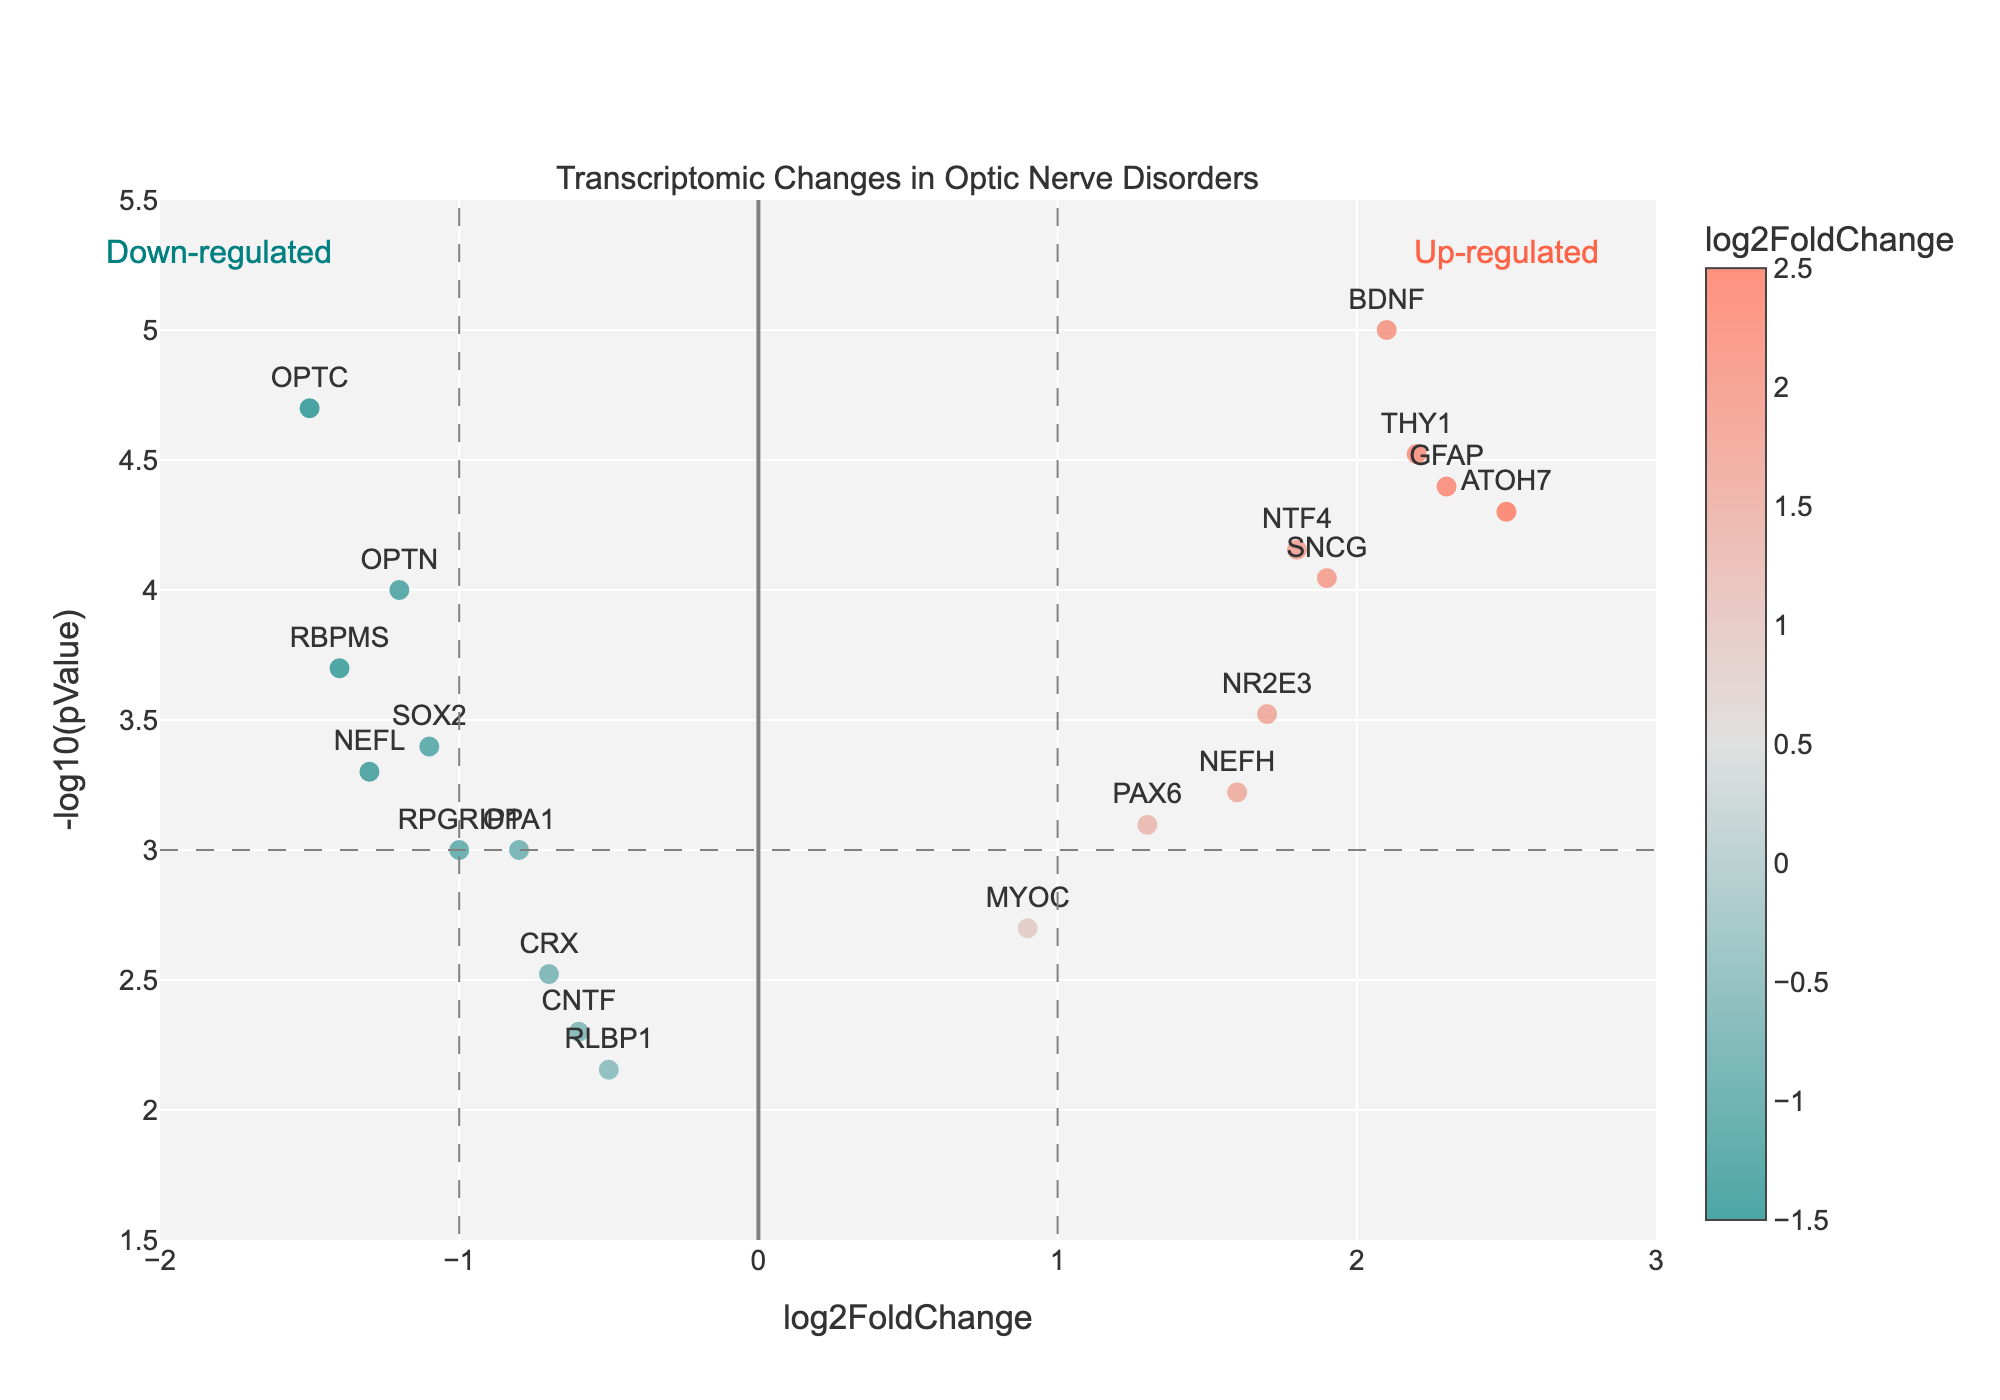What's the title of the plot? The title is usually displayed at the top of the plot, providing an overview of what the plot is about. Here, it is "Transcriptomic Changes in Optic Nerve Disorders."
Answer: Transcriptomic Changes in Optic Nerve Disorders What is represented on the x-axis? The x-axis in a volcano plot typically shows the log2FoldChange, which measures the change in expression levels of genes. It helps in identifying which genes are up-regulated or down-regulated.
Answer: log2FoldChange What is plotted on the y-axis? The y-axis in a volcano plot represents the negative log10 of the p-values (-log10(pValue)). This helps to identify the significance of the changes in gene expression, with higher values indicating more significant changes.
Answer: -log10(pValue) How many genes are up-regulated with a significant p-value (less than 0.001)? To find the number of up-regulated genes with significant p-values, we can visually inspect the right side of the volcano plot (log2FoldChange > 1) and check if their y-values are high (above the threshold line representing p-value < 0.001). Genes like ATOH7, BDNF, GFAP, NTF4, SNCG, and THY1 meet these criteria.
Answer: 6 Which gene shows the highest negative log2FoldChange and how significant is its change? The gene with the most negative log2FoldChange is identified by locating the point farthest to the left on the x-axis. OPTC shows the highest negative log2FoldChange (-1.5). We can also check its significance by its y-value (high on the y-axis), indicating a very significant change.
Answer: OPTC, highly significant (p-value < 0.001) Which gene has the highest expression change post-treatment? The highest expression change (log2FoldChange) can be found by identifying the point farthest to the right on the x-axis. ATOH7 has the highest positive log2FoldChange of 2.5.
Answer: ATOH7 What can you infer about the gene with the lowest significance? The gene with the lowest significance will have the smallest -log10(pValue), which corresponds to the lowest point on the y-axis. RLBP1 has a -log10(pValue) of about 2, indicating it is the least significant among the plotted genes.
Answer: RLBP1 is the least significant Are there more up-regulated or down-regulated genes with p-values < 0.01? To compare, we can count the number of genes with log2FoldChange > 0 (up-regulated) and p-value < 0.01, and those with log2FoldChange < 0 (down-regulated) and p-value < 0.01. There are more up-regulated genes (ATOH7, BDNF, NTF4, GFAP, SNCG, THY1) than down-regulated ones (OPTN, OPTC, RBPMS, NEFL).
Answer: More up-regulated genes (6 vs 4) Which genes are considered highly significant (p-value < 0.0001) and how are they regulated? Highly significant genes are identified by their high -log10(pValue) values. Genes with p-values < 0.0001 (log10(pValue) > 4) are OPTN, ATOH7, OPTC, BDNF, NTF4, GFAP, THY1. According to their log2FoldChange, ATOH7, BDNF, NTF4, GFAP, THY1 are up-regulated, while OPTN and OPTC are down-regulated.
Answer: OPTN (down), ATOH7 (up), OPTC (down), BDNF (up), NTF4 (up), GFAP (up), THY1 (up) 